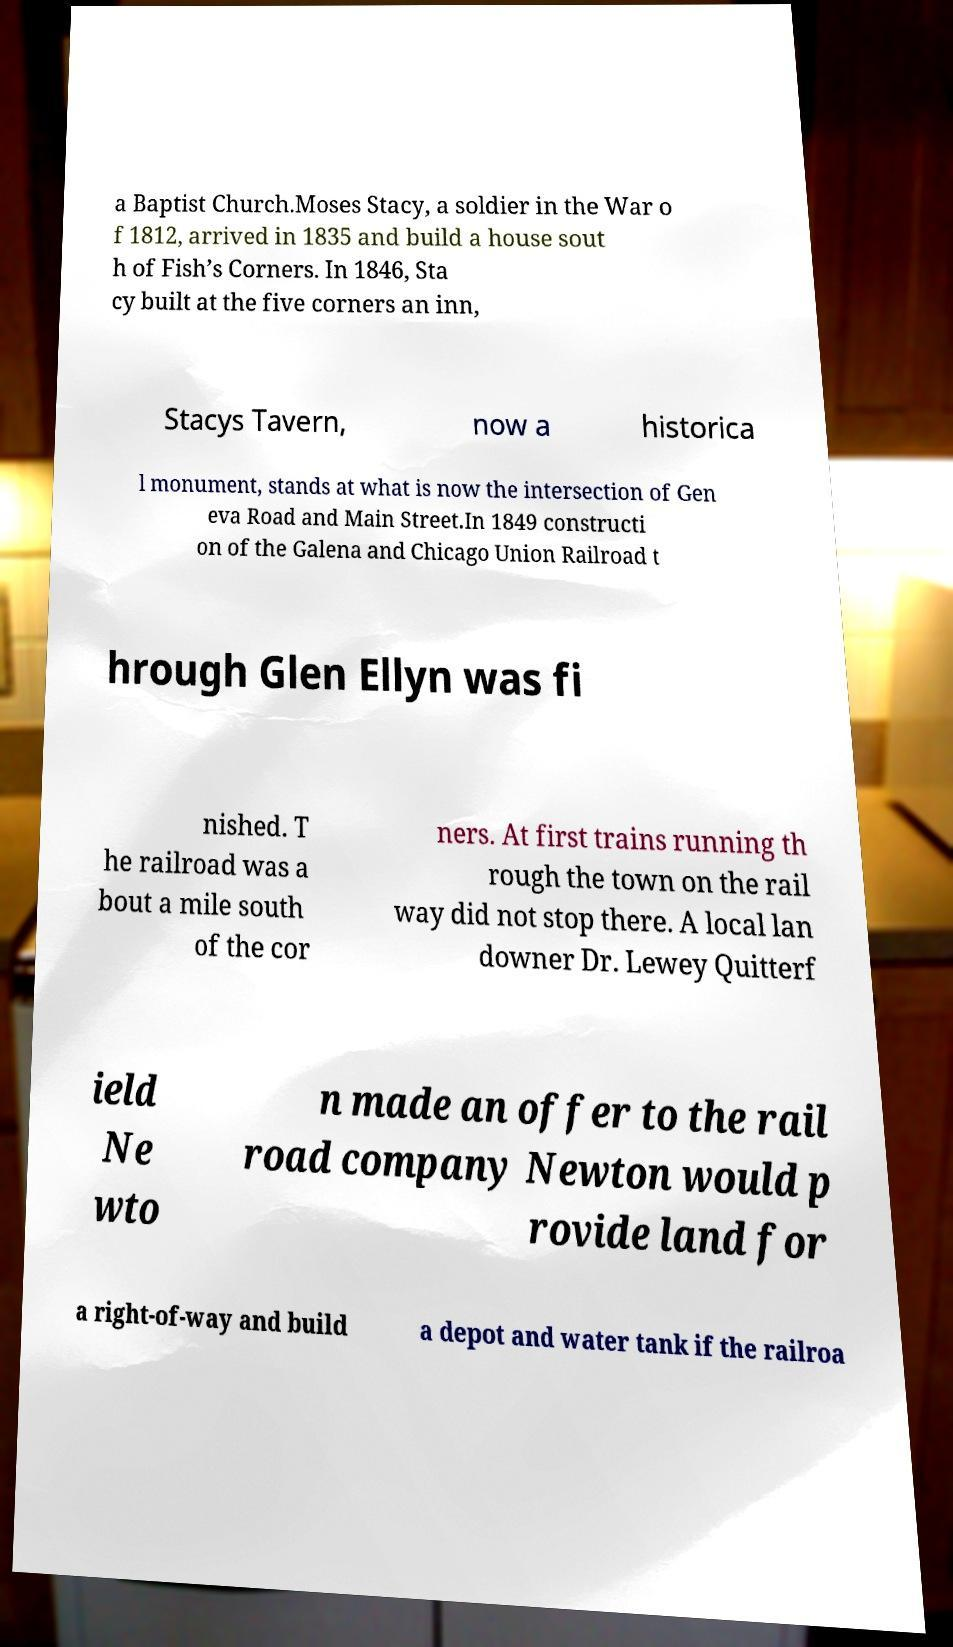Please read and relay the text visible in this image. What does it say? a Baptist Church.Moses Stacy, a soldier in the War o f 1812, arrived in 1835 and build a house sout h of Fish’s Corners. In 1846, Sta cy built at the five corners an inn, Stacys Tavern, now a historica l monument, stands at what is now the intersection of Gen eva Road and Main Street.In 1849 constructi on of the Galena and Chicago Union Railroad t hrough Glen Ellyn was fi nished. T he railroad was a bout a mile south of the cor ners. At first trains running th rough the town on the rail way did not stop there. A local lan downer Dr. Lewey Quitterf ield Ne wto n made an offer to the rail road company Newton would p rovide land for a right-of-way and build a depot and water tank if the railroa 